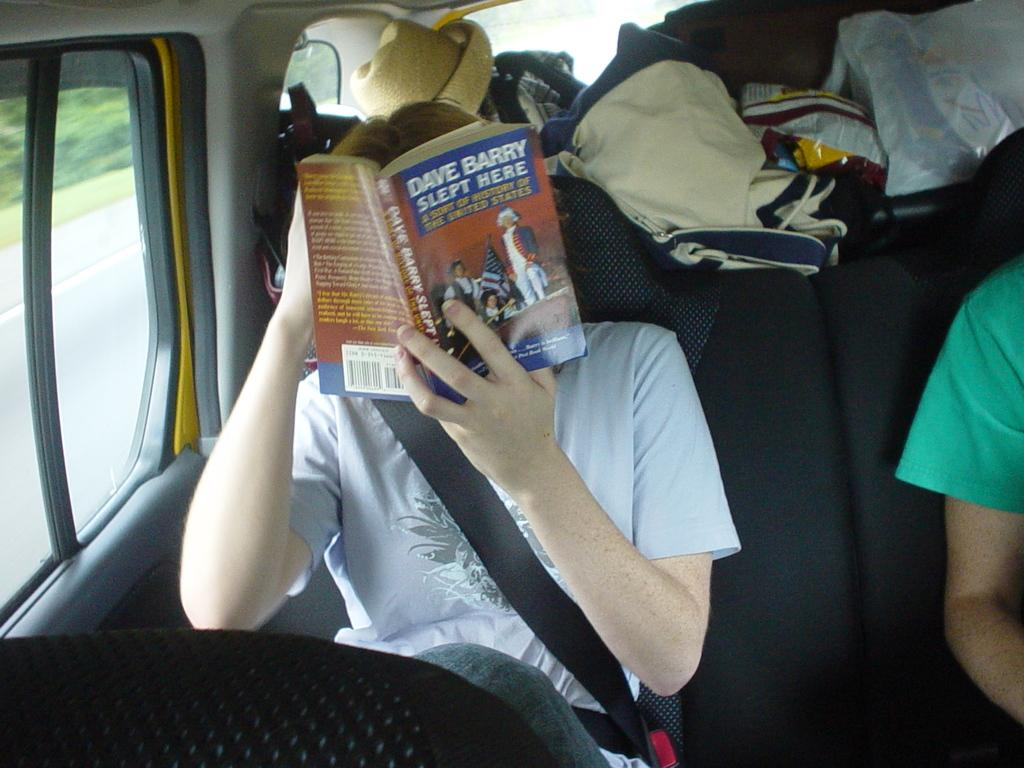<image>
Relay a brief, clear account of the picture shown. Davy Barry Slept Here Book is keeping this person busy on their journey. 